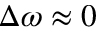Convert formula to latex. <formula><loc_0><loc_0><loc_500><loc_500>\Delta \omega \approx 0</formula> 